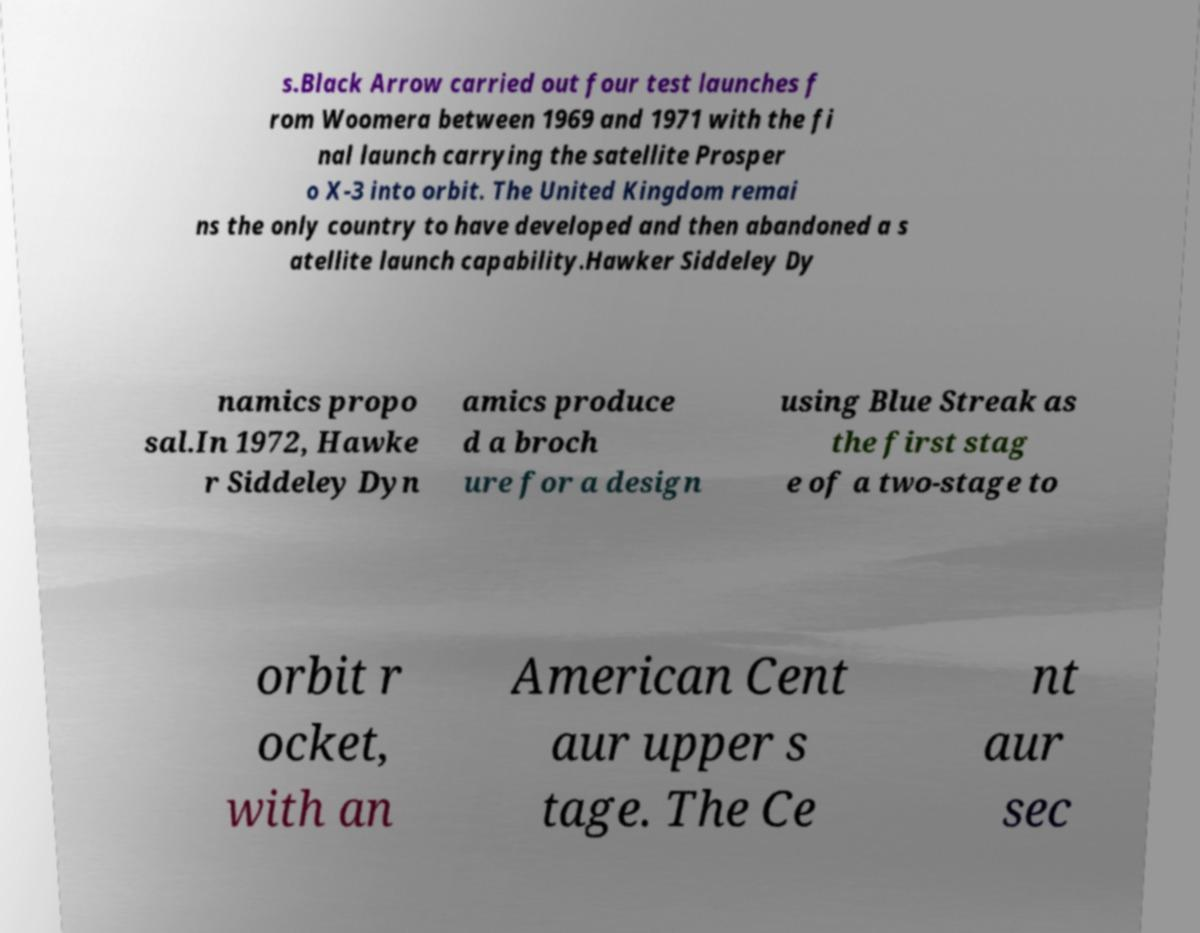For documentation purposes, I need the text within this image transcribed. Could you provide that? s.Black Arrow carried out four test launches f rom Woomera between 1969 and 1971 with the fi nal launch carrying the satellite Prosper o X-3 into orbit. The United Kingdom remai ns the only country to have developed and then abandoned a s atellite launch capability.Hawker Siddeley Dy namics propo sal.In 1972, Hawke r Siddeley Dyn amics produce d a broch ure for a design using Blue Streak as the first stag e of a two-stage to orbit r ocket, with an American Cent aur upper s tage. The Ce nt aur sec 